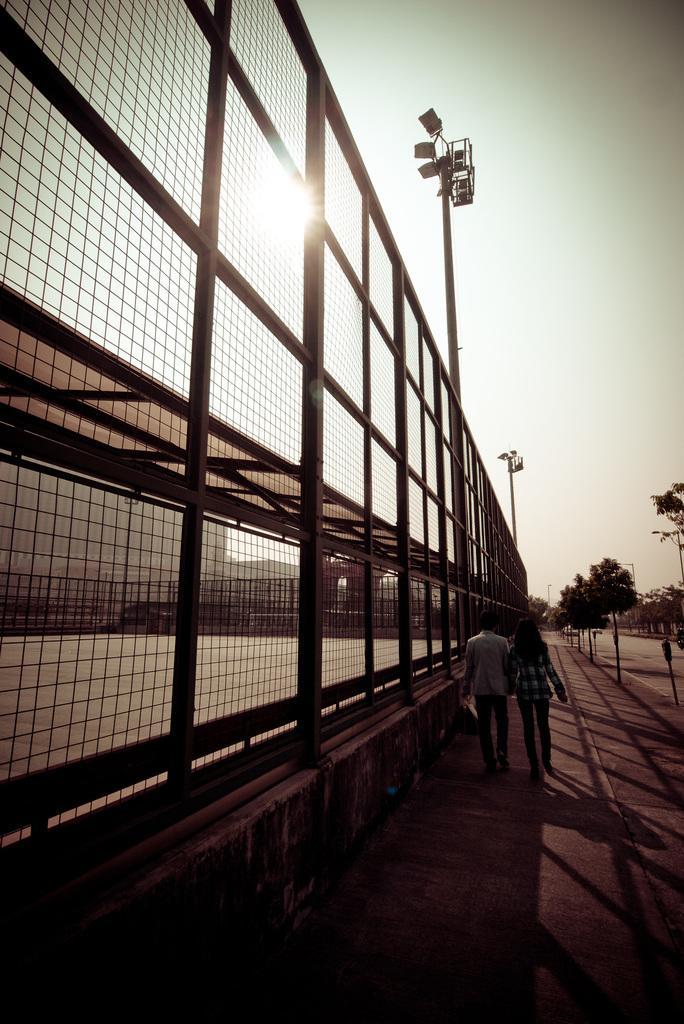In one or two sentences, can you explain what this image depicts? Sky is sunny. In the foreground of the picture there are people walking on the road. On the left there is fencing and there are lights. In the background there are trees. On the left there are buildings. 